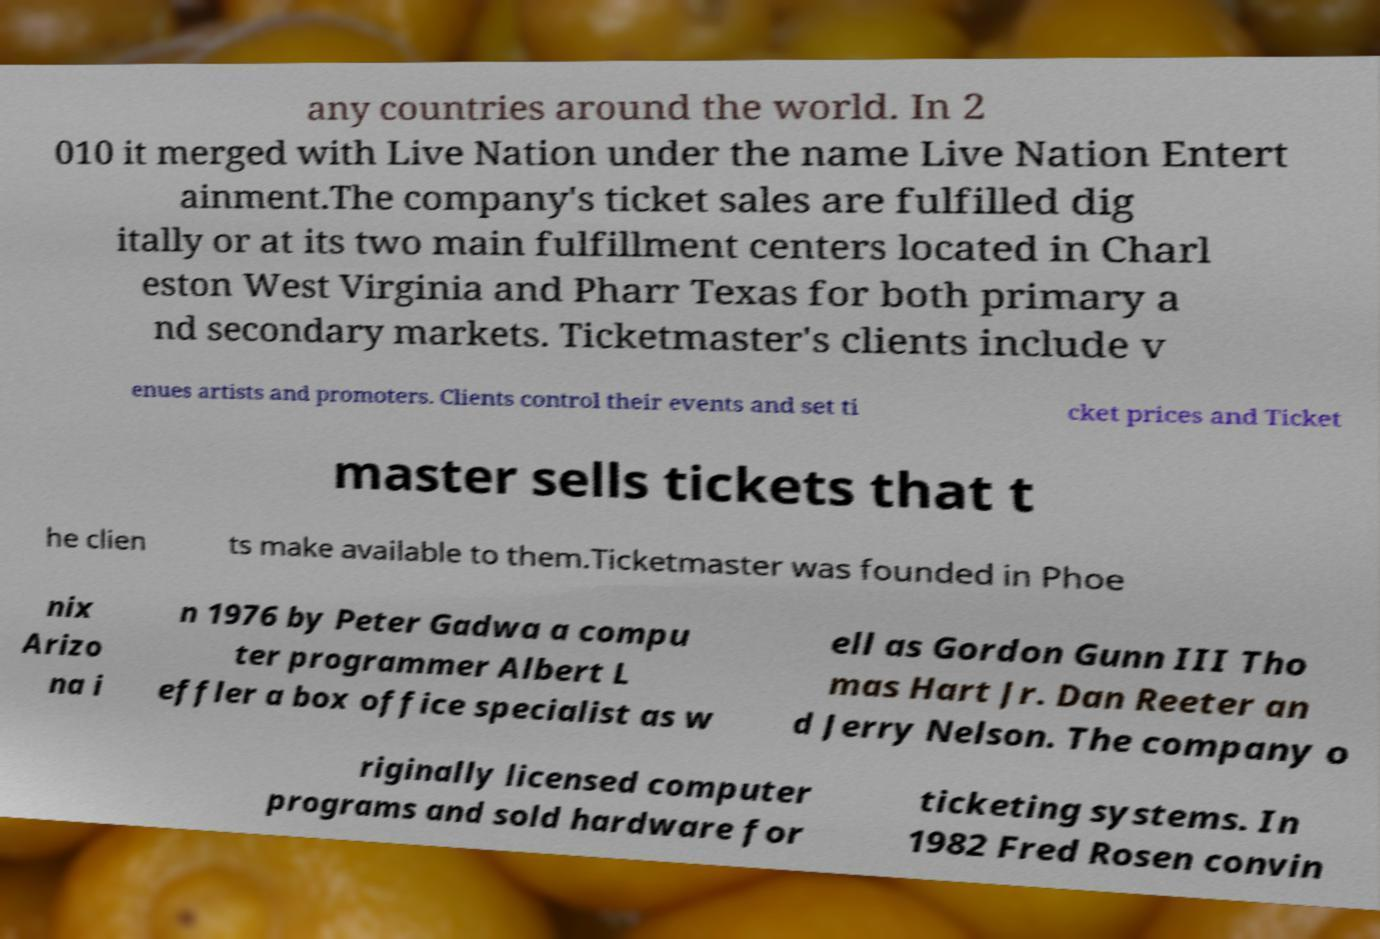What messages or text are displayed in this image? I need them in a readable, typed format. any countries around the world. In 2 010 it merged with Live Nation under the name Live Nation Entert ainment.The company's ticket sales are fulfilled dig itally or at its two main fulfillment centers located in Charl eston West Virginia and Pharr Texas for both primary a nd secondary markets. Ticketmaster's clients include v enues artists and promoters. Clients control their events and set ti cket prices and Ticket master sells tickets that t he clien ts make available to them.Ticketmaster was founded in Phoe nix Arizo na i n 1976 by Peter Gadwa a compu ter programmer Albert L effler a box office specialist as w ell as Gordon Gunn III Tho mas Hart Jr. Dan Reeter an d Jerry Nelson. The company o riginally licensed computer programs and sold hardware for ticketing systems. In 1982 Fred Rosen convin 